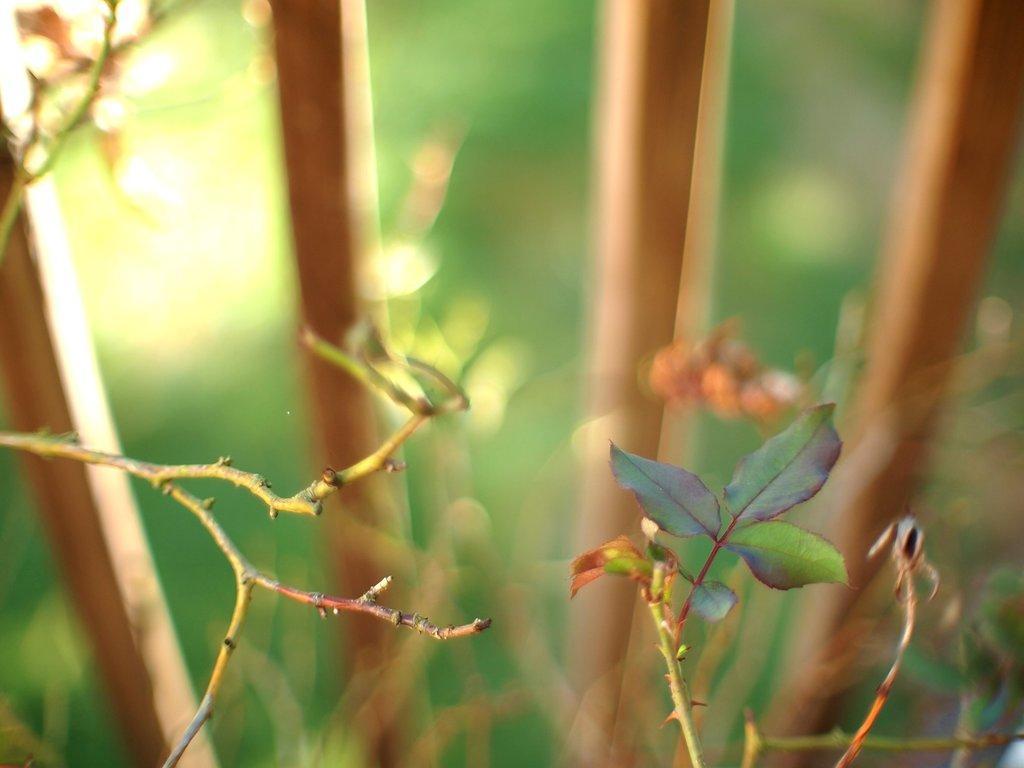Describe this image in one or two sentences. In this image in the foreground there are some leaves, and in the background there are some sticks and some plants. 